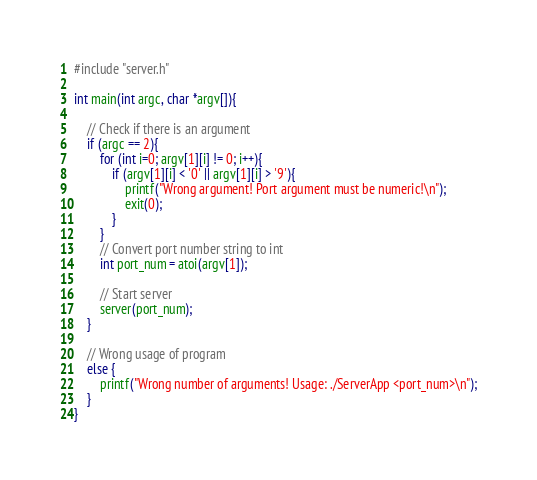<code> <loc_0><loc_0><loc_500><loc_500><_C++_>#include "server.h"

int main(int argc, char *argv[]){

    // Check if there is an argument
    if (argc == 2){
        for (int i=0; argv[1][i] != 0; i++){
            if (argv[1][i] < '0' || argv[1][i] > '9'){
                printf("Wrong argument! Port argument must be numeric!\n");
                exit(0);
            }
        }
        // Convert port number string to int
        int port_num = atoi(argv[1]);

        // Start server
        server(port_num);
    }

    // Wrong usage of program
    else {
        printf("Wrong number of arguments! Usage: ./ServerApp <port_num>\n");
    }
}
</code> 